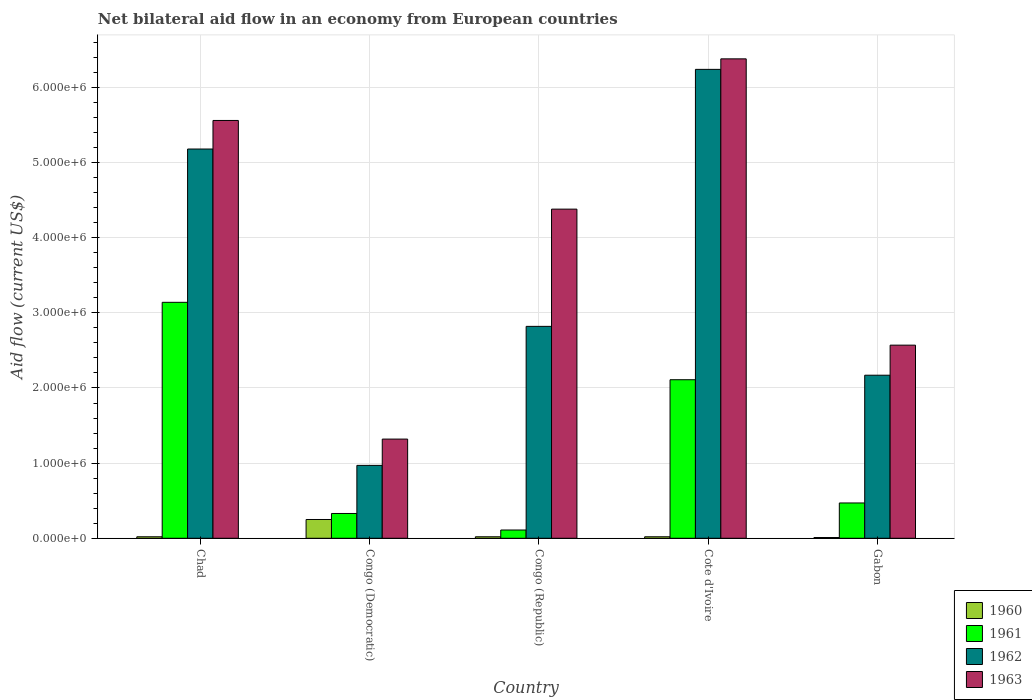How many different coloured bars are there?
Offer a terse response. 4. How many groups of bars are there?
Your answer should be very brief. 5. Are the number of bars per tick equal to the number of legend labels?
Your response must be concise. Yes. Are the number of bars on each tick of the X-axis equal?
Make the answer very short. Yes. How many bars are there on the 2nd tick from the right?
Your answer should be compact. 4. What is the label of the 2nd group of bars from the left?
Your answer should be very brief. Congo (Democratic). In how many cases, is the number of bars for a given country not equal to the number of legend labels?
Your answer should be compact. 0. What is the net bilateral aid flow in 1960 in Congo (Democratic)?
Your answer should be very brief. 2.50e+05. Across all countries, what is the maximum net bilateral aid flow in 1961?
Keep it short and to the point. 3.14e+06. In which country was the net bilateral aid flow in 1963 maximum?
Make the answer very short. Cote d'Ivoire. In which country was the net bilateral aid flow in 1962 minimum?
Make the answer very short. Congo (Democratic). What is the total net bilateral aid flow in 1963 in the graph?
Offer a very short reply. 2.02e+07. What is the difference between the net bilateral aid flow in 1963 in Chad and that in Cote d'Ivoire?
Offer a terse response. -8.20e+05. What is the difference between the net bilateral aid flow in 1961 in Congo (Democratic) and the net bilateral aid flow in 1963 in Gabon?
Offer a very short reply. -2.24e+06. What is the average net bilateral aid flow in 1960 per country?
Offer a very short reply. 6.40e+04. What is the difference between the net bilateral aid flow of/in 1961 and net bilateral aid flow of/in 1963 in Chad?
Your answer should be very brief. -2.42e+06. What is the ratio of the net bilateral aid flow in 1962 in Chad to that in Cote d'Ivoire?
Your answer should be compact. 0.83. Is the net bilateral aid flow in 1963 in Chad less than that in Gabon?
Keep it short and to the point. No. Is the difference between the net bilateral aid flow in 1961 in Chad and Gabon greater than the difference between the net bilateral aid flow in 1963 in Chad and Gabon?
Provide a succinct answer. No. What is the difference between the highest and the second highest net bilateral aid flow in 1962?
Provide a short and direct response. 1.06e+06. What is the difference between the highest and the lowest net bilateral aid flow in 1960?
Offer a terse response. 2.40e+05. In how many countries, is the net bilateral aid flow in 1961 greater than the average net bilateral aid flow in 1961 taken over all countries?
Your answer should be compact. 2. What does the 2nd bar from the right in Congo (Democratic) represents?
Give a very brief answer. 1962. Is it the case that in every country, the sum of the net bilateral aid flow in 1960 and net bilateral aid flow in 1963 is greater than the net bilateral aid flow in 1962?
Offer a terse response. Yes. How many bars are there?
Ensure brevity in your answer.  20. Are all the bars in the graph horizontal?
Provide a short and direct response. No. How many countries are there in the graph?
Offer a terse response. 5. Where does the legend appear in the graph?
Make the answer very short. Bottom right. How many legend labels are there?
Offer a terse response. 4. What is the title of the graph?
Give a very brief answer. Net bilateral aid flow in an economy from European countries. What is the label or title of the X-axis?
Ensure brevity in your answer.  Country. What is the Aid flow (current US$) in 1960 in Chad?
Give a very brief answer. 2.00e+04. What is the Aid flow (current US$) in 1961 in Chad?
Give a very brief answer. 3.14e+06. What is the Aid flow (current US$) in 1962 in Chad?
Make the answer very short. 5.18e+06. What is the Aid flow (current US$) of 1963 in Chad?
Keep it short and to the point. 5.56e+06. What is the Aid flow (current US$) in 1962 in Congo (Democratic)?
Ensure brevity in your answer.  9.70e+05. What is the Aid flow (current US$) in 1963 in Congo (Democratic)?
Provide a succinct answer. 1.32e+06. What is the Aid flow (current US$) in 1962 in Congo (Republic)?
Offer a very short reply. 2.82e+06. What is the Aid flow (current US$) in 1963 in Congo (Republic)?
Offer a terse response. 4.38e+06. What is the Aid flow (current US$) in 1961 in Cote d'Ivoire?
Your answer should be compact. 2.11e+06. What is the Aid flow (current US$) of 1962 in Cote d'Ivoire?
Your answer should be compact. 6.24e+06. What is the Aid flow (current US$) in 1963 in Cote d'Ivoire?
Offer a terse response. 6.38e+06. What is the Aid flow (current US$) in 1961 in Gabon?
Offer a terse response. 4.70e+05. What is the Aid flow (current US$) of 1962 in Gabon?
Ensure brevity in your answer.  2.17e+06. What is the Aid flow (current US$) of 1963 in Gabon?
Your answer should be very brief. 2.57e+06. Across all countries, what is the maximum Aid flow (current US$) of 1960?
Provide a short and direct response. 2.50e+05. Across all countries, what is the maximum Aid flow (current US$) in 1961?
Make the answer very short. 3.14e+06. Across all countries, what is the maximum Aid flow (current US$) of 1962?
Your response must be concise. 6.24e+06. Across all countries, what is the maximum Aid flow (current US$) in 1963?
Give a very brief answer. 6.38e+06. Across all countries, what is the minimum Aid flow (current US$) of 1960?
Your answer should be very brief. 10000. Across all countries, what is the minimum Aid flow (current US$) of 1962?
Your response must be concise. 9.70e+05. Across all countries, what is the minimum Aid flow (current US$) of 1963?
Your answer should be very brief. 1.32e+06. What is the total Aid flow (current US$) in 1961 in the graph?
Offer a terse response. 6.16e+06. What is the total Aid flow (current US$) of 1962 in the graph?
Offer a very short reply. 1.74e+07. What is the total Aid flow (current US$) in 1963 in the graph?
Offer a very short reply. 2.02e+07. What is the difference between the Aid flow (current US$) in 1960 in Chad and that in Congo (Democratic)?
Your answer should be compact. -2.30e+05. What is the difference between the Aid flow (current US$) of 1961 in Chad and that in Congo (Democratic)?
Your response must be concise. 2.81e+06. What is the difference between the Aid flow (current US$) in 1962 in Chad and that in Congo (Democratic)?
Your answer should be very brief. 4.21e+06. What is the difference between the Aid flow (current US$) in 1963 in Chad and that in Congo (Democratic)?
Offer a terse response. 4.24e+06. What is the difference between the Aid flow (current US$) in 1961 in Chad and that in Congo (Republic)?
Provide a succinct answer. 3.03e+06. What is the difference between the Aid flow (current US$) of 1962 in Chad and that in Congo (Republic)?
Your answer should be very brief. 2.36e+06. What is the difference between the Aid flow (current US$) of 1963 in Chad and that in Congo (Republic)?
Provide a short and direct response. 1.18e+06. What is the difference between the Aid flow (current US$) in 1961 in Chad and that in Cote d'Ivoire?
Your answer should be compact. 1.03e+06. What is the difference between the Aid flow (current US$) in 1962 in Chad and that in Cote d'Ivoire?
Make the answer very short. -1.06e+06. What is the difference between the Aid flow (current US$) of 1963 in Chad and that in Cote d'Ivoire?
Offer a very short reply. -8.20e+05. What is the difference between the Aid flow (current US$) of 1961 in Chad and that in Gabon?
Provide a short and direct response. 2.67e+06. What is the difference between the Aid flow (current US$) of 1962 in Chad and that in Gabon?
Your answer should be very brief. 3.01e+06. What is the difference between the Aid flow (current US$) of 1963 in Chad and that in Gabon?
Your answer should be very brief. 2.99e+06. What is the difference between the Aid flow (current US$) in 1962 in Congo (Democratic) and that in Congo (Republic)?
Make the answer very short. -1.85e+06. What is the difference between the Aid flow (current US$) in 1963 in Congo (Democratic) and that in Congo (Republic)?
Offer a very short reply. -3.06e+06. What is the difference between the Aid flow (current US$) in 1960 in Congo (Democratic) and that in Cote d'Ivoire?
Ensure brevity in your answer.  2.30e+05. What is the difference between the Aid flow (current US$) in 1961 in Congo (Democratic) and that in Cote d'Ivoire?
Keep it short and to the point. -1.78e+06. What is the difference between the Aid flow (current US$) in 1962 in Congo (Democratic) and that in Cote d'Ivoire?
Provide a short and direct response. -5.27e+06. What is the difference between the Aid flow (current US$) in 1963 in Congo (Democratic) and that in Cote d'Ivoire?
Offer a very short reply. -5.06e+06. What is the difference between the Aid flow (current US$) in 1960 in Congo (Democratic) and that in Gabon?
Make the answer very short. 2.40e+05. What is the difference between the Aid flow (current US$) of 1961 in Congo (Democratic) and that in Gabon?
Your response must be concise. -1.40e+05. What is the difference between the Aid flow (current US$) in 1962 in Congo (Democratic) and that in Gabon?
Make the answer very short. -1.20e+06. What is the difference between the Aid flow (current US$) in 1963 in Congo (Democratic) and that in Gabon?
Provide a succinct answer. -1.25e+06. What is the difference between the Aid flow (current US$) in 1960 in Congo (Republic) and that in Cote d'Ivoire?
Offer a terse response. 0. What is the difference between the Aid flow (current US$) in 1961 in Congo (Republic) and that in Cote d'Ivoire?
Offer a very short reply. -2.00e+06. What is the difference between the Aid flow (current US$) of 1962 in Congo (Republic) and that in Cote d'Ivoire?
Offer a very short reply. -3.42e+06. What is the difference between the Aid flow (current US$) of 1960 in Congo (Republic) and that in Gabon?
Provide a succinct answer. 10000. What is the difference between the Aid flow (current US$) of 1961 in Congo (Republic) and that in Gabon?
Offer a terse response. -3.60e+05. What is the difference between the Aid flow (current US$) in 1962 in Congo (Republic) and that in Gabon?
Provide a short and direct response. 6.50e+05. What is the difference between the Aid flow (current US$) in 1963 in Congo (Republic) and that in Gabon?
Give a very brief answer. 1.81e+06. What is the difference between the Aid flow (current US$) of 1960 in Cote d'Ivoire and that in Gabon?
Give a very brief answer. 10000. What is the difference between the Aid flow (current US$) of 1961 in Cote d'Ivoire and that in Gabon?
Your answer should be compact. 1.64e+06. What is the difference between the Aid flow (current US$) in 1962 in Cote d'Ivoire and that in Gabon?
Provide a short and direct response. 4.07e+06. What is the difference between the Aid flow (current US$) of 1963 in Cote d'Ivoire and that in Gabon?
Give a very brief answer. 3.81e+06. What is the difference between the Aid flow (current US$) in 1960 in Chad and the Aid flow (current US$) in 1961 in Congo (Democratic)?
Make the answer very short. -3.10e+05. What is the difference between the Aid flow (current US$) in 1960 in Chad and the Aid flow (current US$) in 1962 in Congo (Democratic)?
Your answer should be very brief. -9.50e+05. What is the difference between the Aid flow (current US$) of 1960 in Chad and the Aid flow (current US$) of 1963 in Congo (Democratic)?
Keep it short and to the point. -1.30e+06. What is the difference between the Aid flow (current US$) of 1961 in Chad and the Aid flow (current US$) of 1962 in Congo (Democratic)?
Your answer should be compact. 2.17e+06. What is the difference between the Aid flow (current US$) of 1961 in Chad and the Aid flow (current US$) of 1963 in Congo (Democratic)?
Offer a very short reply. 1.82e+06. What is the difference between the Aid flow (current US$) of 1962 in Chad and the Aid flow (current US$) of 1963 in Congo (Democratic)?
Provide a short and direct response. 3.86e+06. What is the difference between the Aid flow (current US$) of 1960 in Chad and the Aid flow (current US$) of 1961 in Congo (Republic)?
Offer a very short reply. -9.00e+04. What is the difference between the Aid flow (current US$) of 1960 in Chad and the Aid flow (current US$) of 1962 in Congo (Republic)?
Provide a succinct answer. -2.80e+06. What is the difference between the Aid flow (current US$) of 1960 in Chad and the Aid flow (current US$) of 1963 in Congo (Republic)?
Your answer should be compact. -4.36e+06. What is the difference between the Aid flow (current US$) in 1961 in Chad and the Aid flow (current US$) in 1963 in Congo (Republic)?
Offer a very short reply. -1.24e+06. What is the difference between the Aid flow (current US$) of 1960 in Chad and the Aid flow (current US$) of 1961 in Cote d'Ivoire?
Provide a succinct answer. -2.09e+06. What is the difference between the Aid flow (current US$) of 1960 in Chad and the Aid flow (current US$) of 1962 in Cote d'Ivoire?
Your answer should be very brief. -6.22e+06. What is the difference between the Aid flow (current US$) of 1960 in Chad and the Aid flow (current US$) of 1963 in Cote d'Ivoire?
Provide a succinct answer. -6.36e+06. What is the difference between the Aid flow (current US$) in 1961 in Chad and the Aid flow (current US$) in 1962 in Cote d'Ivoire?
Keep it short and to the point. -3.10e+06. What is the difference between the Aid flow (current US$) of 1961 in Chad and the Aid flow (current US$) of 1963 in Cote d'Ivoire?
Provide a succinct answer. -3.24e+06. What is the difference between the Aid flow (current US$) of 1962 in Chad and the Aid flow (current US$) of 1963 in Cote d'Ivoire?
Make the answer very short. -1.20e+06. What is the difference between the Aid flow (current US$) in 1960 in Chad and the Aid flow (current US$) in 1961 in Gabon?
Offer a terse response. -4.50e+05. What is the difference between the Aid flow (current US$) of 1960 in Chad and the Aid flow (current US$) of 1962 in Gabon?
Provide a short and direct response. -2.15e+06. What is the difference between the Aid flow (current US$) in 1960 in Chad and the Aid flow (current US$) in 1963 in Gabon?
Ensure brevity in your answer.  -2.55e+06. What is the difference between the Aid flow (current US$) in 1961 in Chad and the Aid flow (current US$) in 1962 in Gabon?
Your answer should be compact. 9.70e+05. What is the difference between the Aid flow (current US$) in 1961 in Chad and the Aid flow (current US$) in 1963 in Gabon?
Provide a succinct answer. 5.70e+05. What is the difference between the Aid flow (current US$) in 1962 in Chad and the Aid flow (current US$) in 1963 in Gabon?
Make the answer very short. 2.61e+06. What is the difference between the Aid flow (current US$) in 1960 in Congo (Democratic) and the Aid flow (current US$) in 1961 in Congo (Republic)?
Offer a terse response. 1.40e+05. What is the difference between the Aid flow (current US$) of 1960 in Congo (Democratic) and the Aid flow (current US$) of 1962 in Congo (Republic)?
Provide a short and direct response. -2.57e+06. What is the difference between the Aid flow (current US$) in 1960 in Congo (Democratic) and the Aid flow (current US$) in 1963 in Congo (Republic)?
Ensure brevity in your answer.  -4.13e+06. What is the difference between the Aid flow (current US$) in 1961 in Congo (Democratic) and the Aid flow (current US$) in 1962 in Congo (Republic)?
Your answer should be very brief. -2.49e+06. What is the difference between the Aid flow (current US$) of 1961 in Congo (Democratic) and the Aid flow (current US$) of 1963 in Congo (Republic)?
Your answer should be very brief. -4.05e+06. What is the difference between the Aid flow (current US$) in 1962 in Congo (Democratic) and the Aid flow (current US$) in 1963 in Congo (Republic)?
Your answer should be compact. -3.41e+06. What is the difference between the Aid flow (current US$) of 1960 in Congo (Democratic) and the Aid flow (current US$) of 1961 in Cote d'Ivoire?
Provide a succinct answer. -1.86e+06. What is the difference between the Aid flow (current US$) of 1960 in Congo (Democratic) and the Aid flow (current US$) of 1962 in Cote d'Ivoire?
Give a very brief answer. -5.99e+06. What is the difference between the Aid flow (current US$) of 1960 in Congo (Democratic) and the Aid flow (current US$) of 1963 in Cote d'Ivoire?
Offer a terse response. -6.13e+06. What is the difference between the Aid flow (current US$) in 1961 in Congo (Democratic) and the Aid flow (current US$) in 1962 in Cote d'Ivoire?
Keep it short and to the point. -5.91e+06. What is the difference between the Aid flow (current US$) in 1961 in Congo (Democratic) and the Aid flow (current US$) in 1963 in Cote d'Ivoire?
Offer a very short reply. -6.05e+06. What is the difference between the Aid flow (current US$) of 1962 in Congo (Democratic) and the Aid flow (current US$) of 1963 in Cote d'Ivoire?
Offer a terse response. -5.41e+06. What is the difference between the Aid flow (current US$) in 1960 in Congo (Democratic) and the Aid flow (current US$) in 1961 in Gabon?
Give a very brief answer. -2.20e+05. What is the difference between the Aid flow (current US$) in 1960 in Congo (Democratic) and the Aid flow (current US$) in 1962 in Gabon?
Ensure brevity in your answer.  -1.92e+06. What is the difference between the Aid flow (current US$) in 1960 in Congo (Democratic) and the Aid flow (current US$) in 1963 in Gabon?
Offer a terse response. -2.32e+06. What is the difference between the Aid flow (current US$) of 1961 in Congo (Democratic) and the Aid flow (current US$) of 1962 in Gabon?
Your answer should be very brief. -1.84e+06. What is the difference between the Aid flow (current US$) of 1961 in Congo (Democratic) and the Aid flow (current US$) of 1963 in Gabon?
Your answer should be very brief. -2.24e+06. What is the difference between the Aid flow (current US$) in 1962 in Congo (Democratic) and the Aid flow (current US$) in 1963 in Gabon?
Make the answer very short. -1.60e+06. What is the difference between the Aid flow (current US$) of 1960 in Congo (Republic) and the Aid flow (current US$) of 1961 in Cote d'Ivoire?
Provide a short and direct response. -2.09e+06. What is the difference between the Aid flow (current US$) in 1960 in Congo (Republic) and the Aid flow (current US$) in 1962 in Cote d'Ivoire?
Your answer should be compact. -6.22e+06. What is the difference between the Aid flow (current US$) of 1960 in Congo (Republic) and the Aid flow (current US$) of 1963 in Cote d'Ivoire?
Keep it short and to the point. -6.36e+06. What is the difference between the Aid flow (current US$) in 1961 in Congo (Republic) and the Aid flow (current US$) in 1962 in Cote d'Ivoire?
Your response must be concise. -6.13e+06. What is the difference between the Aid flow (current US$) in 1961 in Congo (Republic) and the Aid flow (current US$) in 1963 in Cote d'Ivoire?
Provide a succinct answer. -6.27e+06. What is the difference between the Aid flow (current US$) of 1962 in Congo (Republic) and the Aid flow (current US$) of 1963 in Cote d'Ivoire?
Your answer should be compact. -3.56e+06. What is the difference between the Aid flow (current US$) in 1960 in Congo (Republic) and the Aid flow (current US$) in 1961 in Gabon?
Make the answer very short. -4.50e+05. What is the difference between the Aid flow (current US$) of 1960 in Congo (Republic) and the Aid flow (current US$) of 1962 in Gabon?
Give a very brief answer. -2.15e+06. What is the difference between the Aid flow (current US$) in 1960 in Congo (Republic) and the Aid flow (current US$) in 1963 in Gabon?
Offer a terse response. -2.55e+06. What is the difference between the Aid flow (current US$) in 1961 in Congo (Republic) and the Aid flow (current US$) in 1962 in Gabon?
Ensure brevity in your answer.  -2.06e+06. What is the difference between the Aid flow (current US$) of 1961 in Congo (Republic) and the Aid flow (current US$) of 1963 in Gabon?
Keep it short and to the point. -2.46e+06. What is the difference between the Aid flow (current US$) of 1960 in Cote d'Ivoire and the Aid flow (current US$) of 1961 in Gabon?
Provide a short and direct response. -4.50e+05. What is the difference between the Aid flow (current US$) of 1960 in Cote d'Ivoire and the Aid flow (current US$) of 1962 in Gabon?
Make the answer very short. -2.15e+06. What is the difference between the Aid flow (current US$) in 1960 in Cote d'Ivoire and the Aid flow (current US$) in 1963 in Gabon?
Give a very brief answer. -2.55e+06. What is the difference between the Aid flow (current US$) in 1961 in Cote d'Ivoire and the Aid flow (current US$) in 1963 in Gabon?
Your answer should be very brief. -4.60e+05. What is the difference between the Aid flow (current US$) of 1962 in Cote d'Ivoire and the Aid flow (current US$) of 1963 in Gabon?
Provide a short and direct response. 3.67e+06. What is the average Aid flow (current US$) of 1960 per country?
Ensure brevity in your answer.  6.40e+04. What is the average Aid flow (current US$) of 1961 per country?
Provide a succinct answer. 1.23e+06. What is the average Aid flow (current US$) of 1962 per country?
Keep it short and to the point. 3.48e+06. What is the average Aid flow (current US$) of 1963 per country?
Make the answer very short. 4.04e+06. What is the difference between the Aid flow (current US$) of 1960 and Aid flow (current US$) of 1961 in Chad?
Keep it short and to the point. -3.12e+06. What is the difference between the Aid flow (current US$) in 1960 and Aid flow (current US$) in 1962 in Chad?
Provide a succinct answer. -5.16e+06. What is the difference between the Aid flow (current US$) in 1960 and Aid flow (current US$) in 1963 in Chad?
Provide a succinct answer. -5.54e+06. What is the difference between the Aid flow (current US$) of 1961 and Aid flow (current US$) of 1962 in Chad?
Offer a very short reply. -2.04e+06. What is the difference between the Aid flow (current US$) of 1961 and Aid flow (current US$) of 1963 in Chad?
Your answer should be very brief. -2.42e+06. What is the difference between the Aid flow (current US$) of 1962 and Aid flow (current US$) of 1963 in Chad?
Provide a succinct answer. -3.80e+05. What is the difference between the Aid flow (current US$) in 1960 and Aid flow (current US$) in 1962 in Congo (Democratic)?
Your answer should be compact. -7.20e+05. What is the difference between the Aid flow (current US$) in 1960 and Aid flow (current US$) in 1963 in Congo (Democratic)?
Make the answer very short. -1.07e+06. What is the difference between the Aid flow (current US$) in 1961 and Aid flow (current US$) in 1962 in Congo (Democratic)?
Provide a succinct answer. -6.40e+05. What is the difference between the Aid flow (current US$) in 1961 and Aid flow (current US$) in 1963 in Congo (Democratic)?
Offer a very short reply. -9.90e+05. What is the difference between the Aid flow (current US$) in 1962 and Aid flow (current US$) in 1963 in Congo (Democratic)?
Give a very brief answer. -3.50e+05. What is the difference between the Aid flow (current US$) in 1960 and Aid flow (current US$) in 1962 in Congo (Republic)?
Keep it short and to the point. -2.80e+06. What is the difference between the Aid flow (current US$) in 1960 and Aid flow (current US$) in 1963 in Congo (Republic)?
Your response must be concise. -4.36e+06. What is the difference between the Aid flow (current US$) of 1961 and Aid flow (current US$) of 1962 in Congo (Republic)?
Provide a short and direct response. -2.71e+06. What is the difference between the Aid flow (current US$) in 1961 and Aid flow (current US$) in 1963 in Congo (Republic)?
Offer a very short reply. -4.27e+06. What is the difference between the Aid flow (current US$) in 1962 and Aid flow (current US$) in 1963 in Congo (Republic)?
Provide a succinct answer. -1.56e+06. What is the difference between the Aid flow (current US$) of 1960 and Aid flow (current US$) of 1961 in Cote d'Ivoire?
Offer a terse response. -2.09e+06. What is the difference between the Aid flow (current US$) of 1960 and Aid flow (current US$) of 1962 in Cote d'Ivoire?
Provide a succinct answer. -6.22e+06. What is the difference between the Aid flow (current US$) in 1960 and Aid flow (current US$) in 1963 in Cote d'Ivoire?
Provide a short and direct response. -6.36e+06. What is the difference between the Aid flow (current US$) of 1961 and Aid flow (current US$) of 1962 in Cote d'Ivoire?
Make the answer very short. -4.13e+06. What is the difference between the Aid flow (current US$) in 1961 and Aid flow (current US$) in 1963 in Cote d'Ivoire?
Ensure brevity in your answer.  -4.27e+06. What is the difference between the Aid flow (current US$) of 1960 and Aid flow (current US$) of 1961 in Gabon?
Make the answer very short. -4.60e+05. What is the difference between the Aid flow (current US$) of 1960 and Aid flow (current US$) of 1962 in Gabon?
Your answer should be compact. -2.16e+06. What is the difference between the Aid flow (current US$) of 1960 and Aid flow (current US$) of 1963 in Gabon?
Provide a succinct answer. -2.56e+06. What is the difference between the Aid flow (current US$) in 1961 and Aid flow (current US$) in 1962 in Gabon?
Your answer should be compact. -1.70e+06. What is the difference between the Aid flow (current US$) in 1961 and Aid flow (current US$) in 1963 in Gabon?
Ensure brevity in your answer.  -2.10e+06. What is the difference between the Aid flow (current US$) of 1962 and Aid flow (current US$) of 1963 in Gabon?
Ensure brevity in your answer.  -4.00e+05. What is the ratio of the Aid flow (current US$) of 1960 in Chad to that in Congo (Democratic)?
Make the answer very short. 0.08. What is the ratio of the Aid flow (current US$) of 1961 in Chad to that in Congo (Democratic)?
Give a very brief answer. 9.52. What is the ratio of the Aid flow (current US$) of 1962 in Chad to that in Congo (Democratic)?
Your response must be concise. 5.34. What is the ratio of the Aid flow (current US$) of 1963 in Chad to that in Congo (Democratic)?
Provide a succinct answer. 4.21. What is the ratio of the Aid flow (current US$) in 1961 in Chad to that in Congo (Republic)?
Offer a very short reply. 28.55. What is the ratio of the Aid flow (current US$) in 1962 in Chad to that in Congo (Republic)?
Keep it short and to the point. 1.84. What is the ratio of the Aid flow (current US$) in 1963 in Chad to that in Congo (Republic)?
Offer a terse response. 1.27. What is the ratio of the Aid flow (current US$) in 1960 in Chad to that in Cote d'Ivoire?
Give a very brief answer. 1. What is the ratio of the Aid flow (current US$) in 1961 in Chad to that in Cote d'Ivoire?
Provide a succinct answer. 1.49. What is the ratio of the Aid flow (current US$) of 1962 in Chad to that in Cote d'Ivoire?
Provide a short and direct response. 0.83. What is the ratio of the Aid flow (current US$) of 1963 in Chad to that in Cote d'Ivoire?
Your response must be concise. 0.87. What is the ratio of the Aid flow (current US$) in 1961 in Chad to that in Gabon?
Your response must be concise. 6.68. What is the ratio of the Aid flow (current US$) of 1962 in Chad to that in Gabon?
Provide a succinct answer. 2.39. What is the ratio of the Aid flow (current US$) in 1963 in Chad to that in Gabon?
Make the answer very short. 2.16. What is the ratio of the Aid flow (current US$) in 1960 in Congo (Democratic) to that in Congo (Republic)?
Your answer should be compact. 12.5. What is the ratio of the Aid flow (current US$) of 1961 in Congo (Democratic) to that in Congo (Republic)?
Provide a short and direct response. 3. What is the ratio of the Aid flow (current US$) of 1962 in Congo (Democratic) to that in Congo (Republic)?
Your response must be concise. 0.34. What is the ratio of the Aid flow (current US$) of 1963 in Congo (Democratic) to that in Congo (Republic)?
Provide a short and direct response. 0.3. What is the ratio of the Aid flow (current US$) in 1961 in Congo (Democratic) to that in Cote d'Ivoire?
Your response must be concise. 0.16. What is the ratio of the Aid flow (current US$) of 1962 in Congo (Democratic) to that in Cote d'Ivoire?
Provide a short and direct response. 0.16. What is the ratio of the Aid flow (current US$) in 1963 in Congo (Democratic) to that in Cote d'Ivoire?
Make the answer very short. 0.21. What is the ratio of the Aid flow (current US$) in 1960 in Congo (Democratic) to that in Gabon?
Make the answer very short. 25. What is the ratio of the Aid flow (current US$) in 1961 in Congo (Democratic) to that in Gabon?
Provide a succinct answer. 0.7. What is the ratio of the Aid flow (current US$) in 1962 in Congo (Democratic) to that in Gabon?
Keep it short and to the point. 0.45. What is the ratio of the Aid flow (current US$) in 1963 in Congo (Democratic) to that in Gabon?
Your answer should be compact. 0.51. What is the ratio of the Aid flow (current US$) in 1960 in Congo (Republic) to that in Cote d'Ivoire?
Keep it short and to the point. 1. What is the ratio of the Aid flow (current US$) of 1961 in Congo (Republic) to that in Cote d'Ivoire?
Your answer should be compact. 0.05. What is the ratio of the Aid flow (current US$) in 1962 in Congo (Republic) to that in Cote d'Ivoire?
Keep it short and to the point. 0.45. What is the ratio of the Aid flow (current US$) of 1963 in Congo (Republic) to that in Cote d'Ivoire?
Offer a terse response. 0.69. What is the ratio of the Aid flow (current US$) in 1961 in Congo (Republic) to that in Gabon?
Give a very brief answer. 0.23. What is the ratio of the Aid flow (current US$) in 1962 in Congo (Republic) to that in Gabon?
Ensure brevity in your answer.  1.3. What is the ratio of the Aid flow (current US$) of 1963 in Congo (Republic) to that in Gabon?
Provide a succinct answer. 1.7. What is the ratio of the Aid flow (current US$) in 1961 in Cote d'Ivoire to that in Gabon?
Offer a very short reply. 4.49. What is the ratio of the Aid flow (current US$) in 1962 in Cote d'Ivoire to that in Gabon?
Offer a very short reply. 2.88. What is the ratio of the Aid flow (current US$) of 1963 in Cote d'Ivoire to that in Gabon?
Ensure brevity in your answer.  2.48. What is the difference between the highest and the second highest Aid flow (current US$) in 1960?
Ensure brevity in your answer.  2.30e+05. What is the difference between the highest and the second highest Aid flow (current US$) in 1961?
Your answer should be compact. 1.03e+06. What is the difference between the highest and the second highest Aid flow (current US$) of 1962?
Offer a terse response. 1.06e+06. What is the difference between the highest and the second highest Aid flow (current US$) of 1963?
Your answer should be compact. 8.20e+05. What is the difference between the highest and the lowest Aid flow (current US$) in 1960?
Keep it short and to the point. 2.40e+05. What is the difference between the highest and the lowest Aid flow (current US$) in 1961?
Provide a short and direct response. 3.03e+06. What is the difference between the highest and the lowest Aid flow (current US$) of 1962?
Make the answer very short. 5.27e+06. What is the difference between the highest and the lowest Aid flow (current US$) in 1963?
Your answer should be compact. 5.06e+06. 